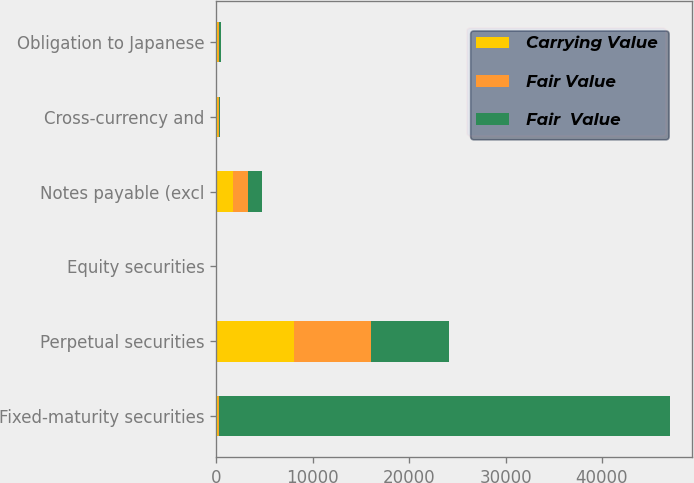Convert chart. <chart><loc_0><loc_0><loc_500><loc_500><stacked_bar_chart><ecel><fcel>Fixed-maturity securities<fcel>Perpetual securities<fcel>Equity securities<fcel>Notes payable (excl<fcel>Cross-currency and<fcel>Obligation to Japanese<nl><fcel>Carrying Value<fcel>161<fcel>8047<fcel>27<fcel>1713<fcel>158<fcel>161<nl><fcel>Fair Value<fcel>161<fcel>8047<fcel>27<fcel>1561<fcel>158<fcel>161<nl><fcel>Fair  Value<fcel>46702<fcel>8023<fcel>28<fcel>1452<fcel>35<fcel>151<nl></chart> 